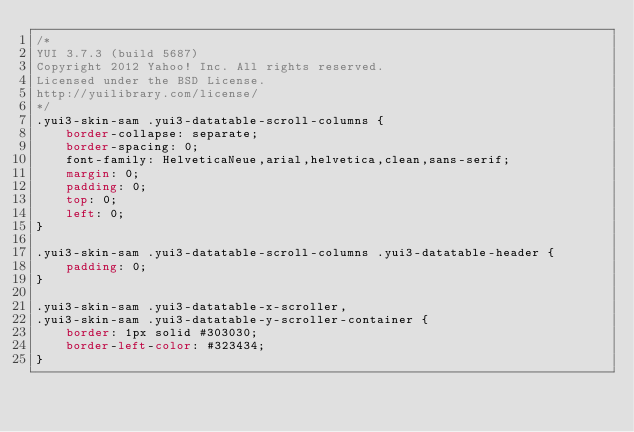Convert code to text. <code><loc_0><loc_0><loc_500><loc_500><_CSS_>/*
YUI 3.7.3 (build 5687)
Copyright 2012 Yahoo! Inc. All rights reserved.
Licensed under the BSD License.
http://yuilibrary.com/license/
*/
.yui3-skin-sam .yui3-datatable-scroll-columns {
    border-collapse: separate;
    border-spacing: 0;
	font-family: HelveticaNeue,arial,helvetica,clean,sans-serif;
    margin: 0;
    padding: 0;
    top: 0;
    left: 0;
}

.yui3-skin-sam .yui3-datatable-scroll-columns .yui3-datatable-header {
    padding: 0;
}

.yui3-skin-sam .yui3-datatable-x-scroller,
.yui3-skin-sam .yui3-datatable-y-scroller-container {
    border: 1px solid #303030;
    border-left-color: #323434;
}
</code> 